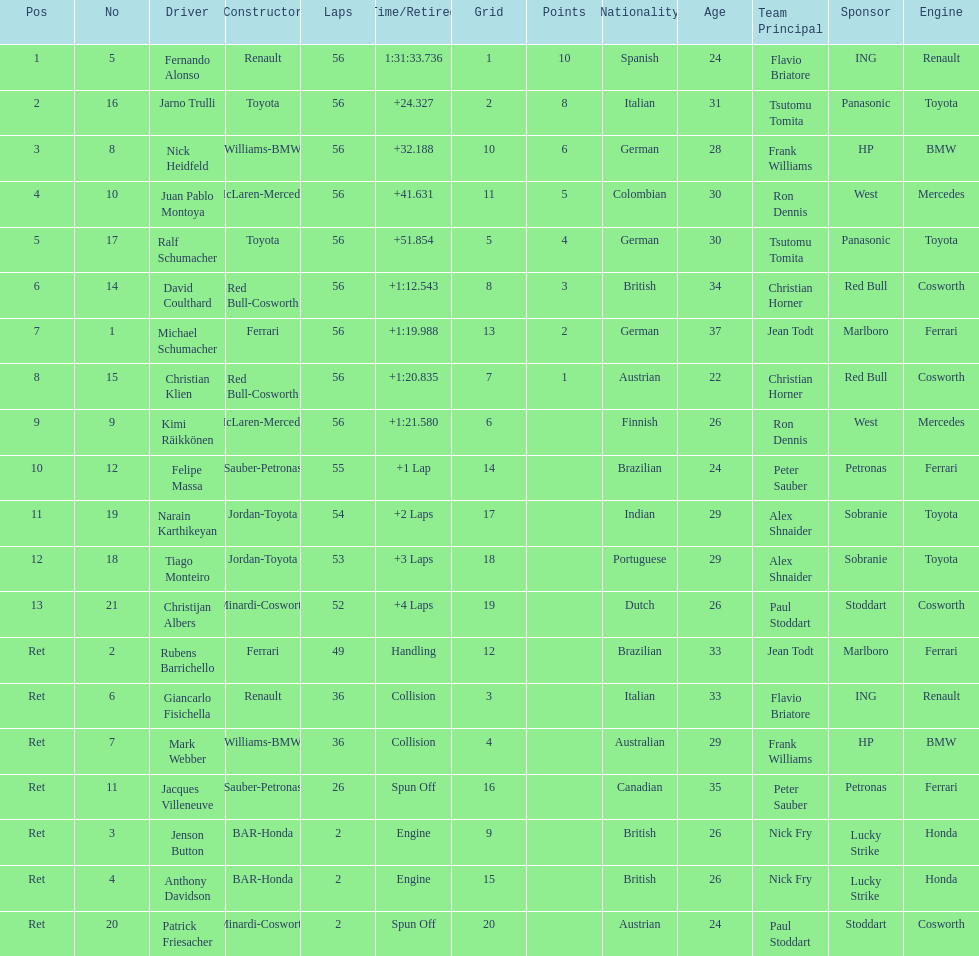How many bmws finished before webber? 1. 